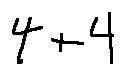<formula> <loc_0><loc_0><loc_500><loc_500>4 + 4</formula> 